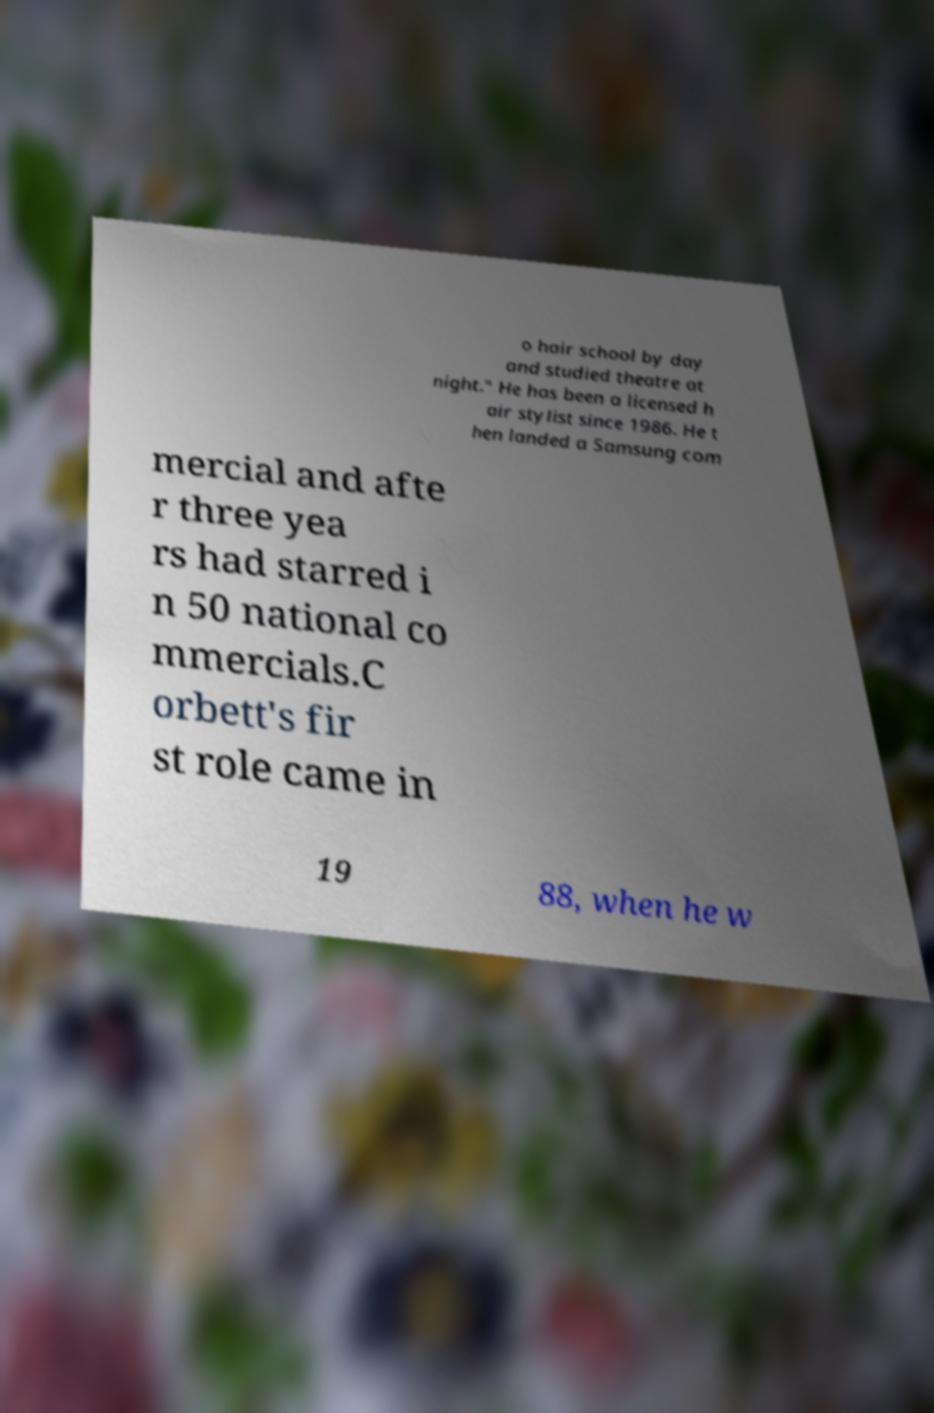For documentation purposes, I need the text within this image transcribed. Could you provide that? o hair school by day and studied theatre at night." He has been a licensed h air stylist since 1986. He t hen landed a Samsung com mercial and afte r three yea rs had starred i n 50 national co mmercials.C orbett's fir st role came in 19 88, when he w 